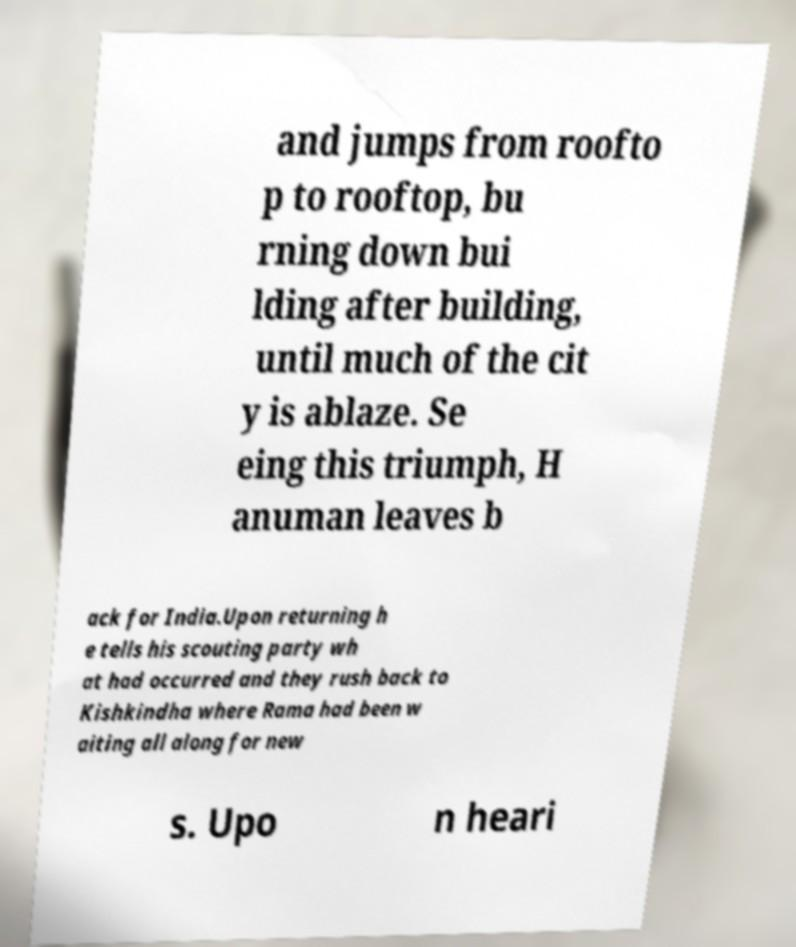Can you read and provide the text displayed in the image?This photo seems to have some interesting text. Can you extract and type it out for me? and jumps from roofto p to rooftop, bu rning down bui lding after building, until much of the cit y is ablaze. Se eing this triumph, H anuman leaves b ack for India.Upon returning h e tells his scouting party wh at had occurred and they rush back to Kishkindha where Rama had been w aiting all along for new s. Upo n heari 